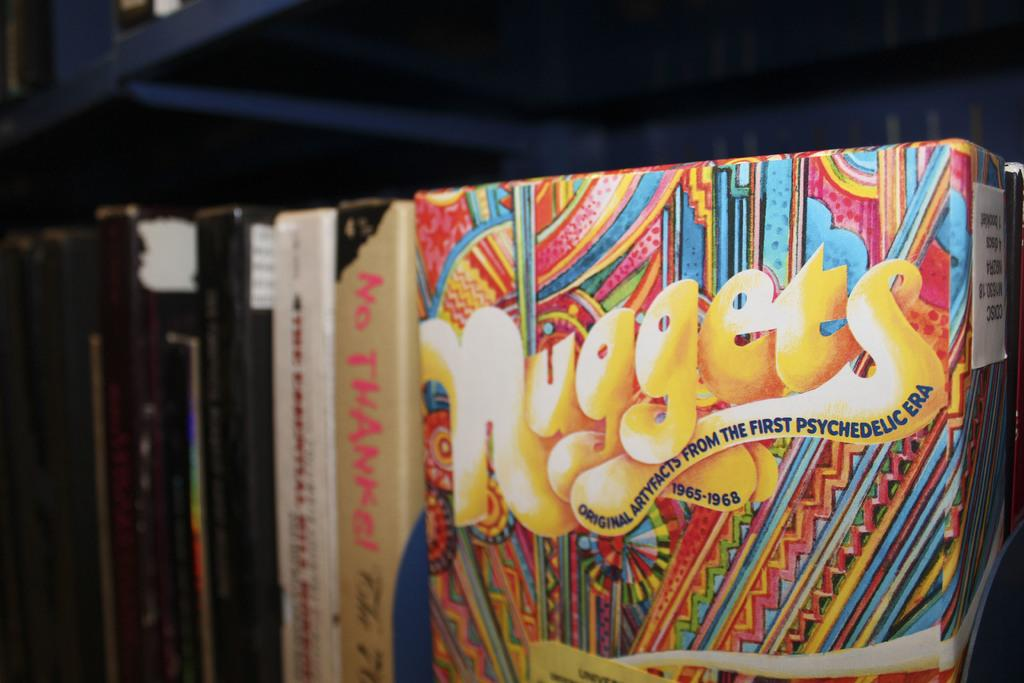<image>
Provide a brief description of the given image. A package of Nuggets from the psychedelic era covers the years 1965 through 1968. 